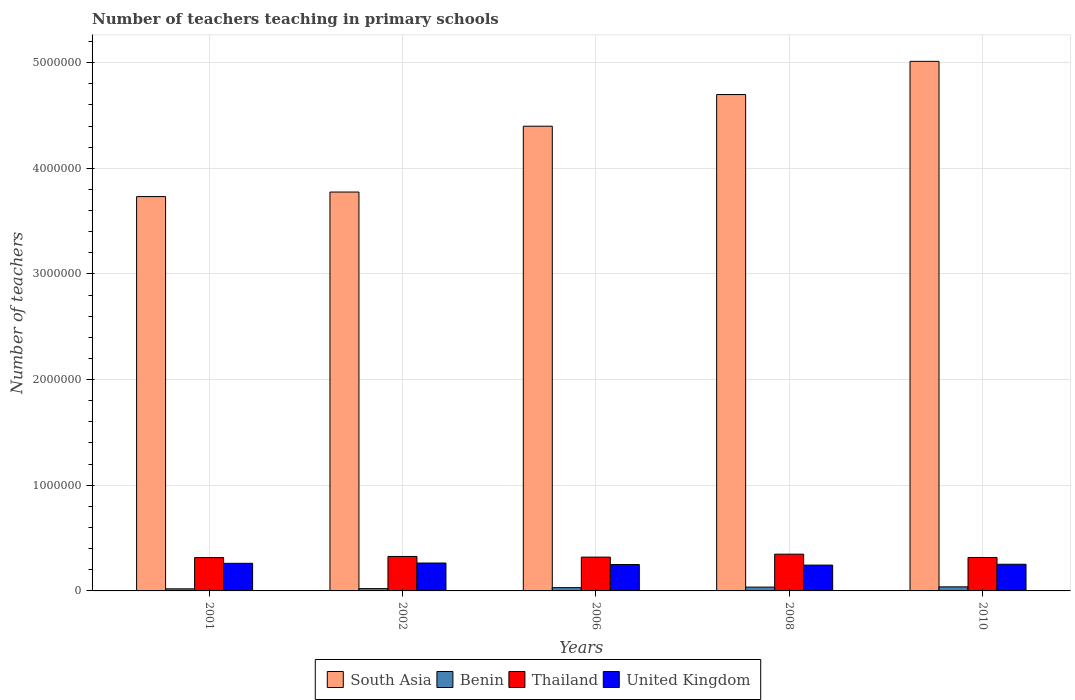How many bars are there on the 5th tick from the left?
Provide a short and direct response. 4. How many bars are there on the 1st tick from the right?
Your answer should be compact. 4. What is the label of the 1st group of bars from the left?
Your answer should be very brief. 2001. In how many cases, is the number of bars for a given year not equal to the number of legend labels?
Provide a succinct answer. 0. What is the number of teachers teaching in primary schools in South Asia in 2010?
Provide a short and direct response. 5.01e+06. Across all years, what is the maximum number of teachers teaching in primary schools in Benin?
Your answer should be compact. 3.85e+04. Across all years, what is the minimum number of teachers teaching in primary schools in Thailand?
Provide a short and direct response. 3.16e+05. What is the total number of teachers teaching in primary schools in Thailand in the graph?
Offer a terse response. 1.63e+06. What is the difference between the number of teachers teaching in primary schools in Thailand in 2001 and that in 2008?
Offer a terse response. -3.24e+04. What is the difference between the number of teachers teaching in primary schools in United Kingdom in 2010 and the number of teachers teaching in primary schools in Benin in 2006?
Give a very brief answer. 2.21e+05. What is the average number of teachers teaching in primary schools in Thailand per year?
Give a very brief answer. 3.25e+05. In the year 2001, what is the difference between the number of teachers teaching in primary schools in Thailand and number of teachers teaching in primary schools in Benin?
Give a very brief answer. 2.96e+05. What is the ratio of the number of teachers teaching in primary schools in United Kingdom in 2002 to that in 2010?
Provide a succinct answer. 1.05. Is the number of teachers teaching in primary schools in United Kingdom in 2001 less than that in 2008?
Your answer should be very brief. No. What is the difference between the highest and the second highest number of teachers teaching in primary schools in South Asia?
Your answer should be compact. 3.14e+05. What is the difference between the highest and the lowest number of teachers teaching in primary schools in Benin?
Provide a succinct answer. 1.88e+04. In how many years, is the number of teachers teaching in primary schools in South Asia greater than the average number of teachers teaching in primary schools in South Asia taken over all years?
Make the answer very short. 3. What does the 3rd bar from the right in 2006 represents?
Provide a succinct answer. Benin. Is it the case that in every year, the sum of the number of teachers teaching in primary schools in Thailand and number of teachers teaching in primary schools in South Asia is greater than the number of teachers teaching in primary schools in United Kingdom?
Make the answer very short. Yes. Are all the bars in the graph horizontal?
Keep it short and to the point. No. How are the legend labels stacked?
Provide a succinct answer. Horizontal. What is the title of the graph?
Your response must be concise. Number of teachers teaching in primary schools. Does "Qatar" appear as one of the legend labels in the graph?
Offer a terse response. No. What is the label or title of the X-axis?
Offer a very short reply. Years. What is the label or title of the Y-axis?
Provide a succinct answer. Number of teachers. What is the Number of teachers in South Asia in 2001?
Offer a very short reply. 3.73e+06. What is the Number of teachers of Benin in 2001?
Make the answer very short. 1.97e+04. What is the Number of teachers in Thailand in 2001?
Ensure brevity in your answer.  3.16e+05. What is the Number of teachers of United Kingdom in 2001?
Your answer should be compact. 2.61e+05. What is the Number of teachers in South Asia in 2002?
Provide a short and direct response. 3.78e+06. What is the Number of teachers in Benin in 2002?
Ensure brevity in your answer.  2.18e+04. What is the Number of teachers in Thailand in 2002?
Ensure brevity in your answer.  3.26e+05. What is the Number of teachers of United Kingdom in 2002?
Provide a short and direct response. 2.64e+05. What is the Number of teachers of South Asia in 2006?
Your response must be concise. 4.40e+06. What is the Number of teachers in Benin in 2006?
Give a very brief answer. 3.11e+04. What is the Number of teachers in Thailand in 2006?
Provide a succinct answer. 3.20e+05. What is the Number of teachers in United Kingdom in 2006?
Provide a succinct answer. 2.50e+05. What is the Number of teachers in South Asia in 2008?
Offer a terse response. 4.70e+06. What is the Number of teachers of Benin in 2008?
Keep it short and to the point. 3.59e+04. What is the Number of teachers in Thailand in 2008?
Your response must be concise. 3.48e+05. What is the Number of teachers of United Kingdom in 2008?
Ensure brevity in your answer.  2.44e+05. What is the Number of teachers in South Asia in 2010?
Keep it short and to the point. 5.01e+06. What is the Number of teachers in Benin in 2010?
Give a very brief answer. 3.85e+04. What is the Number of teachers in Thailand in 2010?
Your answer should be compact. 3.17e+05. What is the Number of teachers of United Kingdom in 2010?
Provide a succinct answer. 2.52e+05. Across all years, what is the maximum Number of teachers in South Asia?
Your answer should be very brief. 5.01e+06. Across all years, what is the maximum Number of teachers in Benin?
Give a very brief answer. 3.85e+04. Across all years, what is the maximum Number of teachers in Thailand?
Ensure brevity in your answer.  3.48e+05. Across all years, what is the maximum Number of teachers in United Kingdom?
Give a very brief answer. 2.64e+05. Across all years, what is the minimum Number of teachers of South Asia?
Offer a terse response. 3.73e+06. Across all years, what is the minimum Number of teachers in Benin?
Provide a succinct answer. 1.97e+04. Across all years, what is the minimum Number of teachers of Thailand?
Your answer should be compact. 3.16e+05. Across all years, what is the minimum Number of teachers in United Kingdom?
Ensure brevity in your answer.  2.44e+05. What is the total Number of teachers in South Asia in the graph?
Provide a succinct answer. 2.16e+07. What is the total Number of teachers in Benin in the graph?
Offer a very short reply. 1.47e+05. What is the total Number of teachers of Thailand in the graph?
Ensure brevity in your answer.  1.63e+06. What is the total Number of teachers in United Kingdom in the graph?
Offer a very short reply. 1.27e+06. What is the difference between the Number of teachers of South Asia in 2001 and that in 2002?
Provide a succinct answer. -4.31e+04. What is the difference between the Number of teachers in Benin in 2001 and that in 2002?
Provide a succinct answer. -2056. What is the difference between the Number of teachers in Thailand in 2001 and that in 2002?
Provide a succinct answer. -1.07e+04. What is the difference between the Number of teachers of United Kingdom in 2001 and that in 2002?
Your answer should be compact. -2749. What is the difference between the Number of teachers of South Asia in 2001 and that in 2006?
Give a very brief answer. -6.66e+05. What is the difference between the Number of teachers in Benin in 2001 and that in 2006?
Provide a succinct answer. -1.14e+04. What is the difference between the Number of teachers of Thailand in 2001 and that in 2006?
Your answer should be compact. -4351. What is the difference between the Number of teachers of United Kingdom in 2001 and that in 2006?
Make the answer very short. 1.15e+04. What is the difference between the Number of teachers of South Asia in 2001 and that in 2008?
Offer a terse response. -9.66e+05. What is the difference between the Number of teachers of Benin in 2001 and that in 2008?
Your answer should be very brief. -1.62e+04. What is the difference between the Number of teachers of Thailand in 2001 and that in 2008?
Your response must be concise. -3.24e+04. What is the difference between the Number of teachers of United Kingdom in 2001 and that in 2008?
Make the answer very short. 1.70e+04. What is the difference between the Number of teachers in South Asia in 2001 and that in 2010?
Give a very brief answer. -1.28e+06. What is the difference between the Number of teachers in Benin in 2001 and that in 2010?
Offer a very short reply. -1.88e+04. What is the difference between the Number of teachers in Thailand in 2001 and that in 2010?
Provide a succinct answer. -987. What is the difference between the Number of teachers in United Kingdom in 2001 and that in 2010?
Make the answer very short. 9072. What is the difference between the Number of teachers in South Asia in 2002 and that in 2006?
Give a very brief answer. -6.23e+05. What is the difference between the Number of teachers in Benin in 2002 and that in 2006?
Provide a short and direct response. -9337. What is the difference between the Number of teachers of Thailand in 2002 and that in 2006?
Offer a terse response. 6356. What is the difference between the Number of teachers of United Kingdom in 2002 and that in 2006?
Make the answer very short. 1.42e+04. What is the difference between the Number of teachers of South Asia in 2002 and that in 2008?
Provide a succinct answer. -9.23e+05. What is the difference between the Number of teachers in Benin in 2002 and that in 2008?
Provide a short and direct response. -1.42e+04. What is the difference between the Number of teachers in Thailand in 2002 and that in 2008?
Ensure brevity in your answer.  -2.17e+04. What is the difference between the Number of teachers in United Kingdom in 2002 and that in 2008?
Provide a short and direct response. 1.97e+04. What is the difference between the Number of teachers in South Asia in 2002 and that in 2010?
Provide a short and direct response. -1.24e+06. What is the difference between the Number of teachers in Benin in 2002 and that in 2010?
Keep it short and to the point. -1.68e+04. What is the difference between the Number of teachers of Thailand in 2002 and that in 2010?
Make the answer very short. 9720. What is the difference between the Number of teachers in United Kingdom in 2002 and that in 2010?
Make the answer very short. 1.18e+04. What is the difference between the Number of teachers in South Asia in 2006 and that in 2008?
Ensure brevity in your answer.  -3.00e+05. What is the difference between the Number of teachers in Benin in 2006 and that in 2008?
Your answer should be compact. -4835. What is the difference between the Number of teachers in Thailand in 2006 and that in 2008?
Offer a very short reply. -2.80e+04. What is the difference between the Number of teachers in United Kingdom in 2006 and that in 2008?
Provide a short and direct response. 5471. What is the difference between the Number of teachers of South Asia in 2006 and that in 2010?
Offer a very short reply. -6.14e+05. What is the difference between the Number of teachers in Benin in 2006 and that in 2010?
Give a very brief answer. -7437. What is the difference between the Number of teachers of Thailand in 2006 and that in 2010?
Provide a short and direct response. 3364. What is the difference between the Number of teachers of United Kingdom in 2006 and that in 2010?
Provide a short and direct response. -2428. What is the difference between the Number of teachers in South Asia in 2008 and that in 2010?
Provide a succinct answer. -3.14e+05. What is the difference between the Number of teachers in Benin in 2008 and that in 2010?
Provide a succinct answer. -2602. What is the difference between the Number of teachers in Thailand in 2008 and that in 2010?
Offer a very short reply. 3.14e+04. What is the difference between the Number of teachers of United Kingdom in 2008 and that in 2010?
Provide a short and direct response. -7899. What is the difference between the Number of teachers in South Asia in 2001 and the Number of teachers in Benin in 2002?
Your response must be concise. 3.71e+06. What is the difference between the Number of teachers in South Asia in 2001 and the Number of teachers in Thailand in 2002?
Your response must be concise. 3.41e+06. What is the difference between the Number of teachers of South Asia in 2001 and the Number of teachers of United Kingdom in 2002?
Keep it short and to the point. 3.47e+06. What is the difference between the Number of teachers of Benin in 2001 and the Number of teachers of Thailand in 2002?
Offer a terse response. -3.07e+05. What is the difference between the Number of teachers of Benin in 2001 and the Number of teachers of United Kingdom in 2002?
Provide a short and direct response. -2.44e+05. What is the difference between the Number of teachers of Thailand in 2001 and the Number of teachers of United Kingdom in 2002?
Ensure brevity in your answer.  5.15e+04. What is the difference between the Number of teachers in South Asia in 2001 and the Number of teachers in Benin in 2006?
Give a very brief answer. 3.70e+06. What is the difference between the Number of teachers in South Asia in 2001 and the Number of teachers in Thailand in 2006?
Make the answer very short. 3.41e+06. What is the difference between the Number of teachers in South Asia in 2001 and the Number of teachers in United Kingdom in 2006?
Your response must be concise. 3.48e+06. What is the difference between the Number of teachers in Benin in 2001 and the Number of teachers in Thailand in 2006?
Give a very brief answer. -3.00e+05. What is the difference between the Number of teachers of Benin in 2001 and the Number of teachers of United Kingdom in 2006?
Offer a very short reply. -2.30e+05. What is the difference between the Number of teachers in Thailand in 2001 and the Number of teachers in United Kingdom in 2006?
Give a very brief answer. 6.57e+04. What is the difference between the Number of teachers of South Asia in 2001 and the Number of teachers of Benin in 2008?
Give a very brief answer. 3.70e+06. What is the difference between the Number of teachers in South Asia in 2001 and the Number of teachers in Thailand in 2008?
Offer a very short reply. 3.38e+06. What is the difference between the Number of teachers of South Asia in 2001 and the Number of teachers of United Kingdom in 2008?
Make the answer very short. 3.49e+06. What is the difference between the Number of teachers in Benin in 2001 and the Number of teachers in Thailand in 2008?
Make the answer very short. -3.28e+05. What is the difference between the Number of teachers of Benin in 2001 and the Number of teachers of United Kingdom in 2008?
Offer a very short reply. -2.25e+05. What is the difference between the Number of teachers of Thailand in 2001 and the Number of teachers of United Kingdom in 2008?
Offer a terse response. 7.12e+04. What is the difference between the Number of teachers of South Asia in 2001 and the Number of teachers of Benin in 2010?
Give a very brief answer. 3.69e+06. What is the difference between the Number of teachers in South Asia in 2001 and the Number of teachers in Thailand in 2010?
Keep it short and to the point. 3.42e+06. What is the difference between the Number of teachers of South Asia in 2001 and the Number of teachers of United Kingdom in 2010?
Offer a terse response. 3.48e+06. What is the difference between the Number of teachers in Benin in 2001 and the Number of teachers in Thailand in 2010?
Provide a short and direct response. -2.97e+05. What is the difference between the Number of teachers in Benin in 2001 and the Number of teachers in United Kingdom in 2010?
Offer a very short reply. -2.33e+05. What is the difference between the Number of teachers of Thailand in 2001 and the Number of teachers of United Kingdom in 2010?
Provide a succinct answer. 6.33e+04. What is the difference between the Number of teachers in South Asia in 2002 and the Number of teachers in Benin in 2006?
Your answer should be compact. 3.74e+06. What is the difference between the Number of teachers of South Asia in 2002 and the Number of teachers of Thailand in 2006?
Offer a very short reply. 3.46e+06. What is the difference between the Number of teachers of South Asia in 2002 and the Number of teachers of United Kingdom in 2006?
Your response must be concise. 3.53e+06. What is the difference between the Number of teachers in Benin in 2002 and the Number of teachers in Thailand in 2006?
Your response must be concise. -2.98e+05. What is the difference between the Number of teachers in Benin in 2002 and the Number of teachers in United Kingdom in 2006?
Your response must be concise. -2.28e+05. What is the difference between the Number of teachers in Thailand in 2002 and the Number of teachers in United Kingdom in 2006?
Make the answer very short. 7.64e+04. What is the difference between the Number of teachers of South Asia in 2002 and the Number of teachers of Benin in 2008?
Make the answer very short. 3.74e+06. What is the difference between the Number of teachers of South Asia in 2002 and the Number of teachers of Thailand in 2008?
Provide a succinct answer. 3.43e+06. What is the difference between the Number of teachers in South Asia in 2002 and the Number of teachers in United Kingdom in 2008?
Your response must be concise. 3.53e+06. What is the difference between the Number of teachers in Benin in 2002 and the Number of teachers in Thailand in 2008?
Provide a succinct answer. -3.26e+05. What is the difference between the Number of teachers of Benin in 2002 and the Number of teachers of United Kingdom in 2008?
Make the answer very short. -2.23e+05. What is the difference between the Number of teachers of Thailand in 2002 and the Number of teachers of United Kingdom in 2008?
Offer a very short reply. 8.19e+04. What is the difference between the Number of teachers of South Asia in 2002 and the Number of teachers of Benin in 2010?
Your answer should be very brief. 3.74e+06. What is the difference between the Number of teachers in South Asia in 2002 and the Number of teachers in Thailand in 2010?
Your response must be concise. 3.46e+06. What is the difference between the Number of teachers in South Asia in 2002 and the Number of teachers in United Kingdom in 2010?
Provide a short and direct response. 3.52e+06. What is the difference between the Number of teachers in Benin in 2002 and the Number of teachers in Thailand in 2010?
Your answer should be compact. -2.95e+05. What is the difference between the Number of teachers in Benin in 2002 and the Number of teachers in United Kingdom in 2010?
Your response must be concise. -2.31e+05. What is the difference between the Number of teachers in Thailand in 2002 and the Number of teachers in United Kingdom in 2010?
Ensure brevity in your answer.  7.40e+04. What is the difference between the Number of teachers of South Asia in 2006 and the Number of teachers of Benin in 2008?
Ensure brevity in your answer.  4.36e+06. What is the difference between the Number of teachers in South Asia in 2006 and the Number of teachers in Thailand in 2008?
Provide a short and direct response. 4.05e+06. What is the difference between the Number of teachers in South Asia in 2006 and the Number of teachers in United Kingdom in 2008?
Your response must be concise. 4.15e+06. What is the difference between the Number of teachers of Benin in 2006 and the Number of teachers of Thailand in 2008?
Offer a terse response. -3.17e+05. What is the difference between the Number of teachers in Benin in 2006 and the Number of teachers in United Kingdom in 2008?
Make the answer very short. -2.13e+05. What is the difference between the Number of teachers in Thailand in 2006 and the Number of teachers in United Kingdom in 2008?
Ensure brevity in your answer.  7.55e+04. What is the difference between the Number of teachers of South Asia in 2006 and the Number of teachers of Benin in 2010?
Your answer should be very brief. 4.36e+06. What is the difference between the Number of teachers in South Asia in 2006 and the Number of teachers in Thailand in 2010?
Your answer should be very brief. 4.08e+06. What is the difference between the Number of teachers of South Asia in 2006 and the Number of teachers of United Kingdom in 2010?
Make the answer very short. 4.15e+06. What is the difference between the Number of teachers of Benin in 2006 and the Number of teachers of Thailand in 2010?
Give a very brief answer. -2.85e+05. What is the difference between the Number of teachers of Benin in 2006 and the Number of teachers of United Kingdom in 2010?
Offer a terse response. -2.21e+05. What is the difference between the Number of teachers in Thailand in 2006 and the Number of teachers in United Kingdom in 2010?
Offer a very short reply. 6.76e+04. What is the difference between the Number of teachers of South Asia in 2008 and the Number of teachers of Benin in 2010?
Make the answer very short. 4.66e+06. What is the difference between the Number of teachers in South Asia in 2008 and the Number of teachers in Thailand in 2010?
Provide a succinct answer. 4.38e+06. What is the difference between the Number of teachers of South Asia in 2008 and the Number of teachers of United Kingdom in 2010?
Ensure brevity in your answer.  4.45e+06. What is the difference between the Number of teachers of Benin in 2008 and the Number of teachers of Thailand in 2010?
Offer a terse response. -2.81e+05. What is the difference between the Number of teachers in Benin in 2008 and the Number of teachers in United Kingdom in 2010?
Offer a very short reply. -2.16e+05. What is the difference between the Number of teachers of Thailand in 2008 and the Number of teachers of United Kingdom in 2010?
Give a very brief answer. 9.57e+04. What is the average Number of teachers of South Asia per year?
Make the answer very short. 4.32e+06. What is the average Number of teachers of Benin per year?
Offer a very short reply. 2.94e+04. What is the average Number of teachers in Thailand per year?
Your answer should be compact. 3.25e+05. What is the average Number of teachers of United Kingdom per year?
Keep it short and to the point. 2.54e+05. In the year 2001, what is the difference between the Number of teachers of South Asia and Number of teachers of Benin?
Your answer should be compact. 3.71e+06. In the year 2001, what is the difference between the Number of teachers in South Asia and Number of teachers in Thailand?
Ensure brevity in your answer.  3.42e+06. In the year 2001, what is the difference between the Number of teachers of South Asia and Number of teachers of United Kingdom?
Give a very brief answer. 3.47e+06. In the year 2001, what is the difference between the Number of teachers in Benin and Number of teachers in Thailand?
Your answer should be very brief. -2.96e+05. In the year 2001, what is the difference between the Number of teachers of Benin and Number of teachers of United Kingdom?
Offer a terse response. -2.42e+05. In the year 2001, what is the difference between the Number of teachers in Thailand and Number of teachers in United Kingdom?
Provide a succinct answer. 5.42e+04. In the year 2002, what is the difference between the Number of teachers of South Asia and Number of teachers of Benin?
Offer a terse response. 3.75e+06. In the year 2002, what is the difference between the Number of teachers in South Asia and Number of teachers in Thailand?
Offer a terse response. 3.45e+06. In the year 2002, what is the difference between the Number of teachers of South Asia and Number of teachers of United Kingdom?
Make the answer very short. 3.51e+06. In the year 2002, what is the difference between the Number of teachers in Benin and Number of teachers in Thailand?
Keep it short and to the point. -3.05e+05. In the year 2002, what is the difference between the Number of teachers in Benin and Number of teachers in United Kingdom?
Ensure brevity in your answer.  -2.42e+05. In the year 2002, what is the difference between the Number of teachers in Thailand and Number of teachers in United Kingdom?
Your answer should be compact. 6.22e+04. In the year 2006, what is the difference between the Number of teachers of South Asia and Number of teachers of Benin?
Make the answer very short. 4.37e+06. In the year 2006, what is the difference between the Number of teachers in South Asia and Number of teachers in Thailand?
Provide a succinct answer. 4.08e+06. In the year 2006, what is the difference between the Number of teachers of South Asia and Number of teachers of United Kingdom?
Ensure brevity in your answer.  4.15e+06. In the year 2006, what is the difference between the Number of teachers of Benin and Number of teachers of Thailand?
Offer a very short reply. -2.89e+05. In the year 2006, what is the difference between the Number of teachers of Benin and Number of teachers of United Kingdom?
Provide a succinct answer. -2.19e+05. In the year 2006, what is the difference between the Number of teachers of Thailand and Number of teachers of United Kingdom?
Give a very brief answer. 7.01e+04. In the year 2008, what is the difference between the Number of teachers in South Asia and Number of teachers in Benin?
Keep it short and to the point. 4.66e+06. In the year 2008, what is the difference between the Number of teachers in South Asia and Number of teachers in Thailand?
Give a very brief answer. 4.35e+06. In the year 2008, what is the difference between the Number of teachers of South Asia and Number of teachers of United Kingdom?
Ensure brevity in your answer.  4.45e+06. In the year 2008, what is the difference between the Number of teachers in Benin and Number of teachers in Thailand?
Your answer should be very brief. -3.12e+05. In the year 2008, what is the difference between the Number of teachers in Benin and Number of teachers in United Kingdom?
Provide a succinct answer. -2.08e+05. In the year 2008, what is the difference between the Number of teachers in Thailand and Number of teachers in United Kingdom?
Make the answer very short. 1.04e+05. In the year 2010, what is the difference between the Number of teachers of South Asia and Number of teachers of Benin?
Your answer should be compact. 4.97e+06. In the year 2010, what is the difference between the Number of teachers of South Asia and Number of teachers of Thailand?
Your answer should be very brief. 4.70e+06. In the year 2010, what is the difference between the Number of teachers in South Asia and Number of teachers in United Kingdom?
Your response must be concise. 4.76e+06. In the year 2010, what is the difference between the Number of teachers in Benin and Number of teachers in Thailand?
Provide a short and direct response. -2.78e+05. In the year 2010, what is the difference between the Number of teachers in Benin and Number of teachers in United Kingdom?
Keep it short and to the point. -2.14e+05. In the year 2010, what is the difference between the Number of teachers in Thailand and Number of teachers in United Kingdom?
Your answer should be compact. 6.43e+04. What is the ratio of the Number of teachers of Benin in 2001 to that in 2002?
Offer a terse response. 0.91. What is the ratio of the Number of teachers of Thailand in 2001 to that in 2002?
Make the answer very short. 0.97. What is the ratio of the Number of teachers in United Kingdom in 2001 to that in 2002?
Make the answer very short. 0.99. What is the ratio of the Number of teachers of South Asia in 2001 to that in 2006?
Your response must be concise. 0.85. What is the ratio of the Number of teachers of Benin in 2001 to that in 2006?
Keep it short and to the point. 0.63. What is the ratio of the Number of teachers of Thailand in 2001 to that in 2006?
Offer a very short reply. 0.99. What is the ratio of the Number of teachers in United Kingdom in 2001 to that in 2006?
Ensure brevity in your answer.  1.05. What is the ratio of the Number of teachers in South Asia in 2001 to that in 2008?
Keep it short and to the point. 0.79. What is the ratio of the Number of teachers of Benin in 2001 to that in 2008?
Provide a short and direct response. 0.55. What is the ratio of the Number of teachers of Thailand in 2001 to that in 2008?
Your answer should be compact. 0.91. What is the ratio of the Number of teachers in United Kingdom in 2001 to that in 2008?
Keep it short and to the point. 1.07. What is the ratio of the Number of teachers of South Asia in 2001 to that in 2010?
Make the answer very short. 0.74. What is the ratio of the Number of teachers of Benin in 2001 to that in 2010?
Provide a succinct answer. 0.51. What is the ratio of the Number of teachers of Thailand in 2001 to that in 2010?
Keep it short and to the point. 1. What is the ratio of the Number of teachers in United Kingdom in 2001 to that in 2010?
Your answer should be very brief. 1.04. What is the ratio of the Number of teachers of South Asia in 2002 to that in 2006?
Ensure brevity in your answer.  0.86. What is the ratio of the Number of teachers of Benin in 2002 to that in 2006?
Provide a succinct answer. 0.7. What is the ratio of the Number of teachers of Thailand in 2002 to that in 2006?
Your response must be concise. 1.02. What is the ratio of the Number of teachers of United Kingdom in 2002 to that in 2006?
Your response must be concise. 1.06. What is the ratio of the Number of teachers of South Asia in 2002 to that in 2008?
Ensure brevity in your answer.  0.8. What is the ratio of the Number of teachers in Benin in 2002 to that in 2008?
Provide a short and direct response. 0.61. What is the ratio of the Number of teachers of Thailand in 2002 to that in 2008?
Keep it short and to the point. 0.94. What is the ratio of the Number of teachers of United Kingdom in 2002 to that in 2008?
Offer a terse response. 1.08. What is the ratio of the Number of teachers in South Asia in 2002 to that in 2010?
Make the answer very short. 0.75. What is the ratio of the Number of teachers of Benin in 2002 to that in 2010?
Your response must be concise. 0.56. What is the ratio of the Number of teachers of Thailand in 2002 to that in 2010?
Provide a short and direct response. 1.03. What is the ratio of the Number of teachers in United Kingdom in 2002 to that in 2010?
Your answer should be compact. 1.05. What is the ratio of the Number of teachers of South Asia in 2006 to that in 2008?
Give a very brief answer. 0.94. What is the ratio of the Number of teachers of Benin in 2006 to that in 2008?
Provide a succinct answer. 0.87. What is the ratio of the Number of teachers of Thailand in 2006 to that in 2008?
Your response must be concise. 0.92. What is the ratio of the Number of teachers in United Kingdom in 2006 to that in 2008?
Keep it short and to the point. 1.02. What is the ratio of the Number of teachers in South Asia in 2006 to that in 2010?
Give a very brief answer. 0.88. What is the ratio of the Number of teachers in Benin in 2006 to that in 2010?
Provide a succinct answer. 0.81. What is the ratio of the Number of teachers of Thailand in 2006 to that in 2010?
Your answer should be very brief. 1.01. What is the ratio of the Number of teachers in South Asia in 2008 to that in 2010?
Make the answer very short. 0.94. What is the ratio of the Number of teachers in Benin in 2008 to that in 2010?
Give a very brief answer. 0.93. What is the ratio of the Number of teachers in Thailand in 2008 to that in 2010?
Ensure brevity in your answer.  1.1. What is the ratio of the Number of teachers of United Kingdom in 2008 to that in 2010?
Make the answer very short. 0.97. What is the difference between the highest and the second highest Number of teachers in South Asia?
Offer a very short reply. 3.14e+05. What is the difference between the highest and the second highest Number of teachers of Benin?
Provide a short and direct response. 2602. What is the difference between the highest and the second highest Number of teachers of Thailand?
Provide a short and direct response. 2.17e+04. What is the difference between the highest and the second highest Number of teachers of United Kingdom?
Make the answer very short. 2749. What is the difference between the highest and the lowest Number of teachers in South Asia?
Make the answer very short. 1.28e+06. What is the difference between the highest and the lowest Number of teachers of Benin?
Your response must be concise. 1.88e+04. What is the difference between the highest and the lowest Number of teachers of Thailand?
Ensure brevity in your answer.  3.24e+04. What is the difference between the highest and the lowest Number of teachers in United Kingdom?
Your answer should be very brief. 1.97e+04. 